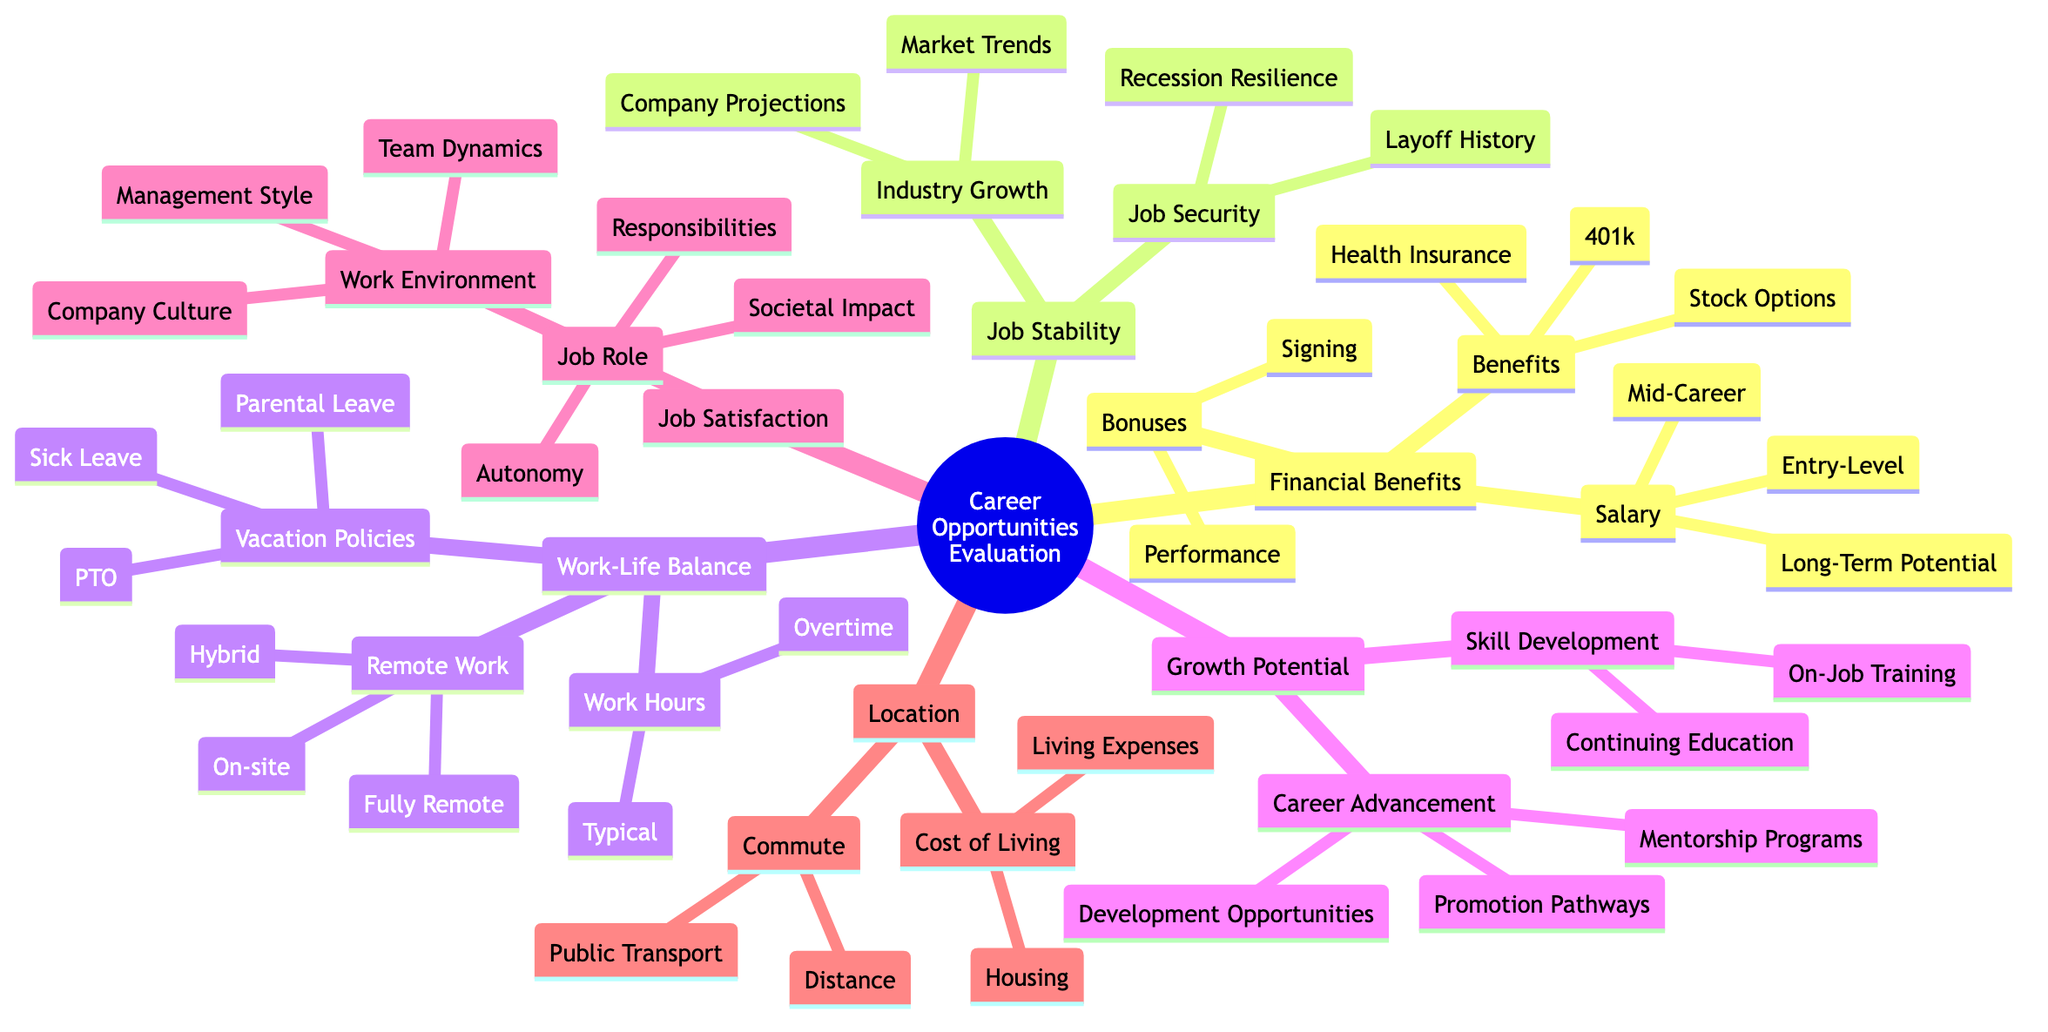What are the subcategories under Financial Benefits? The diagram lists three main subcategories under Financial Benefits: Salary, Bonuses, and Benefits.
Answer: Salary, Bonuses, Benefits How many elements are there under Job Stability? Under Job Stability, there are two main elements: Industry Growth and Job Security. Each of these elements has two subcategories. Therefore, the total number of elements is four.
Answer: 4 Which subcategory focuses on work-related time management? The subcategory that deals with time management related to work is Work Hours, which includes aspects like Typical Work Hours and Overtime Requirements.
Answer: Work Hours What is the highest category that leads to Skill Development? The highest category that leads to Skill Development is Growth Potential, which includes the specific subcategory for Skill Development.
Answer: Growth Potential Under Work-Life Balance, what are the options for Remote Work? The options listed under Remote Work in the Work-Life Balance category are Fully Remote, Hybrid, and On-site.
Answer: Fully Remote, Hybrid, On-site Which two factors are listed under Job Security? The factors listed under Job Security are Recession Resilience and Company Layoff History.
Answer: Recession Resilience, Company Layoff History What type of training is mentioned under Growth Potential? The type of training mentioned under Growth Potential is On-the-Job Training, which focuses on skills acquired while working.
Answer: On-the-Job Training How many aspects are evaluated under Location? The Location category evaluates two aspects: Commute and Cost of Living.
Answer: 2 Which subcategory includes vacation-related policies? The subcategory that includes vacation-related policies is Vacation Policies, which consists of Paid Time Off, Sick Leave, and Parental Leave.
Answer: Vacation Policies 